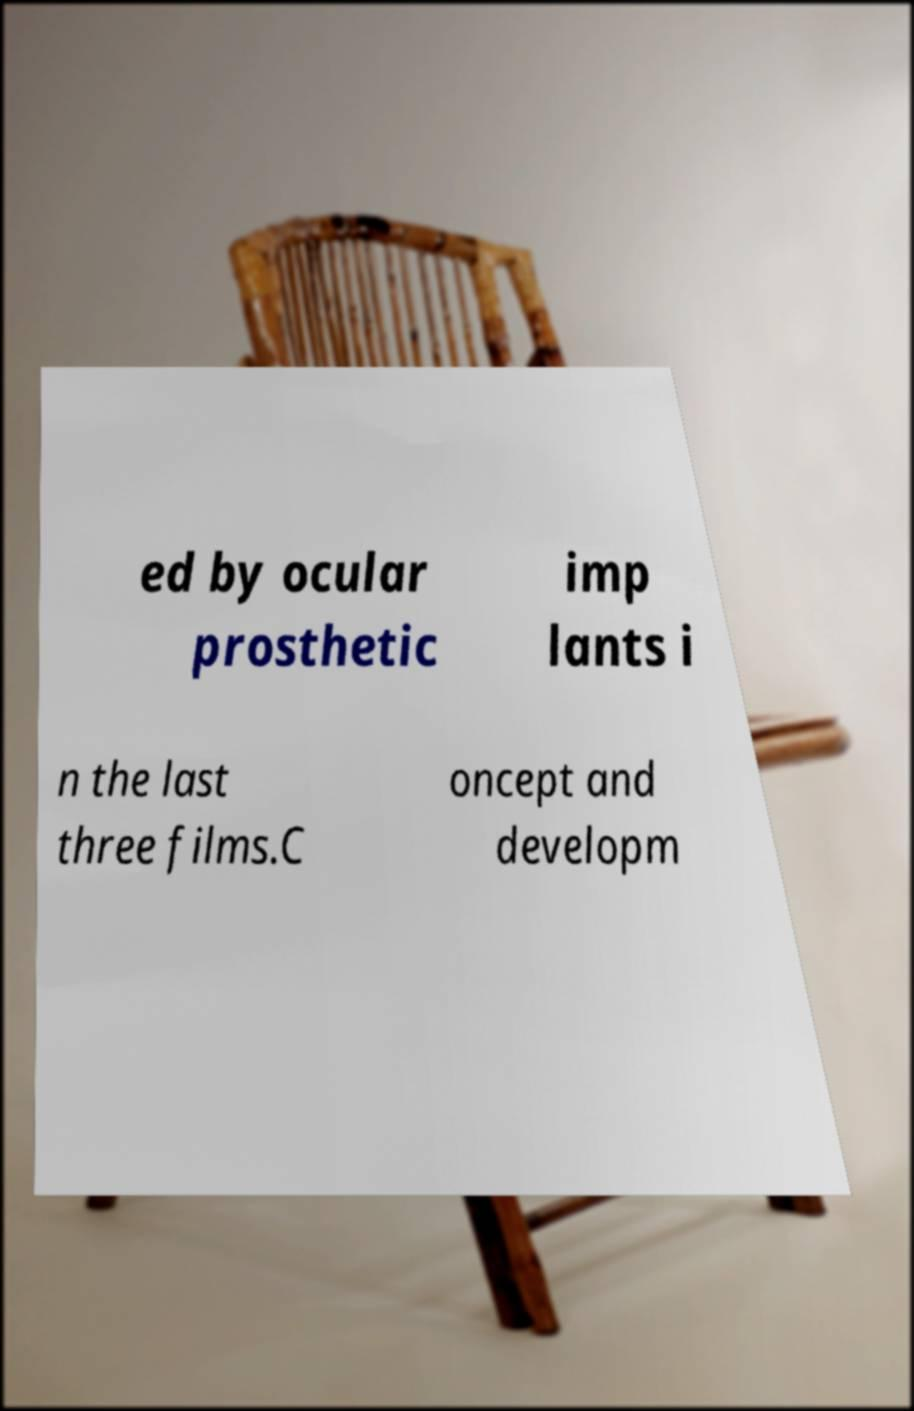Could you assist in decoding the text presented in this image and type it out clearly? ed by ocular prosthetic imp lants i n the last three films.C oncept and developm 